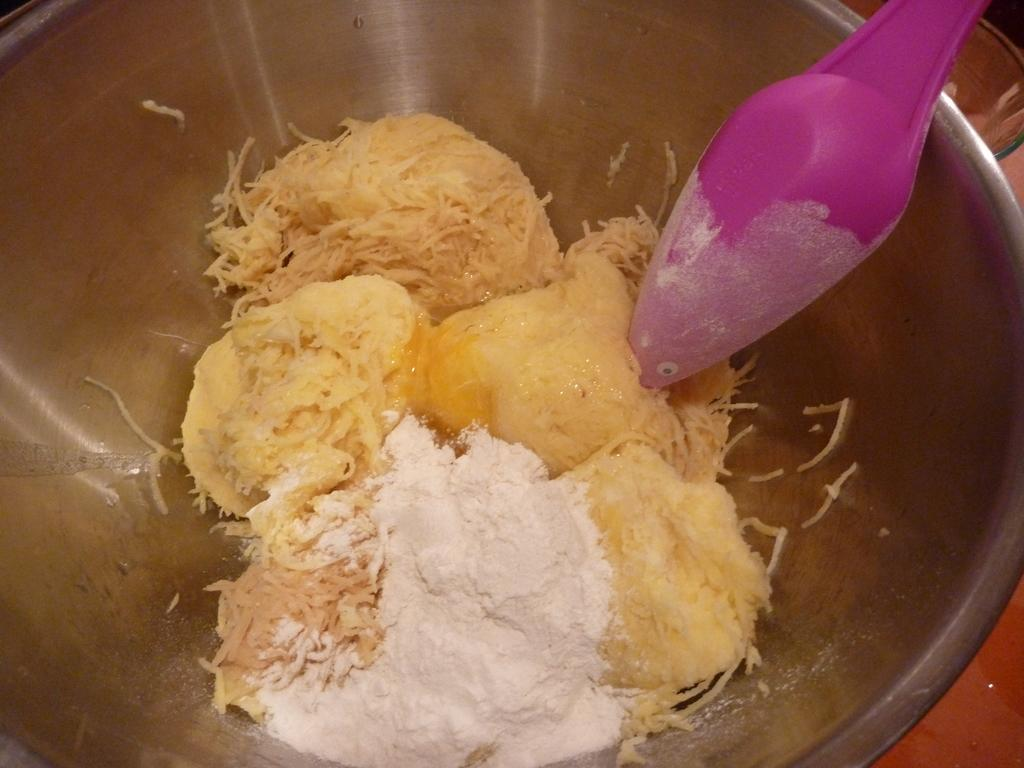What is in the bowl that is visible in the image? The bowl contains food. What utensil is present in the bowl? There is a spoon in the bowl. Where is the bowl located in the image? The bowl is placed on a table. What type of structure is being fought over in the image? There is no structure or fight present in the image; it features a bowl with food and a spoon on a table. 